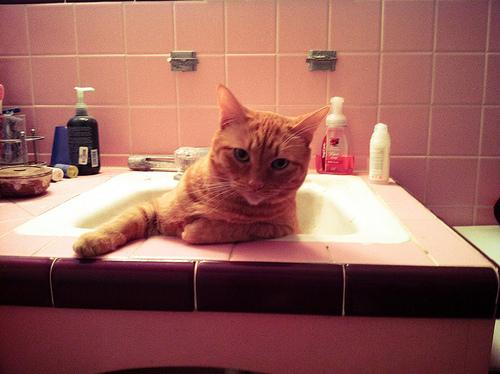In one sentence, describe the primary focus of the image and its setting. The image captures a whimsical moment of a cat resting in a bathroom sink, framed by pink tiles and toiletries. Mention the most interesting item in the picture. A quirky scene unfolds with an orange cat relaxing in a white sink amidst a bathroom with a pink-tiled wall. Briefly describe the subject of the picture and the environment it is in. A tabby cat finds comfort inside a white sink, surrounded by pink bathroom tiles, a black and pink soap dispenser, and other bathroom accessories. Describe the image as if you were telling a brief story to a child. Once upon a time, in a bathroom with magical pink tiles, a curious orange cat decided that the round white sink was the perfect spot for a comfy nap, surrounded by a kingdom of soaps and bottles. Choose a few simple words to describe the main action taking place in the image. Cat lounging in sink, surrounded by pink tiles and bathroom items. Provide a brief summary of the primary object in the image and their surroundings. An orange tabby cat is lying inside a white sink in a bathroom with pink tiles on the wall and various items on the counter. Explain what the most striking feature of the image is and how it relates to the context. The bright-eyed green gaze of a tabby cat lying in a white sink adds a touch of playfulness to the cozy pink-tiled bathroom scene. Write a short sentence identifying the main aspect of the image. The image features an orange striped cat resting in a white sink with pink wall tiles. Explain what the main character in the image is doing and what objects are around them. An orange tabby cat occupies a white sink, with its paw resting on the pink tiled edge, soap dispensers, and a toothbrush holder scattered nearby. Describe the scene or event as if you were narrating it for a visually impaired person. Imagine a cozy bathroom setting, with an adorable orange cat comfortably lounging inside a white sink, surrounded by pink tiled walls and various toiletries on the counter. 